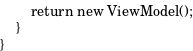Convert code to text. <code><loc_0><loc_0><loc_500><loc_500><_PHP_>        return new ViewModel();
    }
}
</code> 